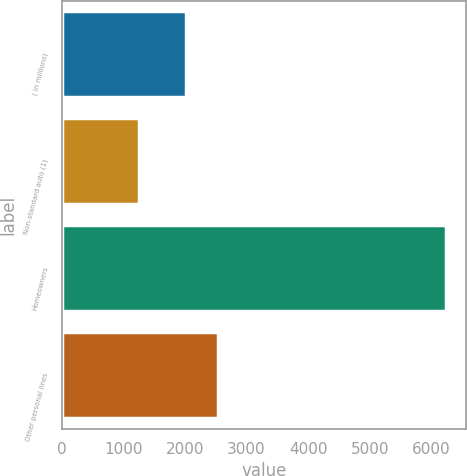Convert chart to OTSL. <chart><loc_0><loc_0><loc_500><loc_500><bar_chart><fcel>( in millions)<fcel>Non-standard auto (1)<fcel>Homeowners<fcel>Other personal lines<nl><fcel>2007<fcel>1247<fcel>6249<fcel>2527<nl></chart> 